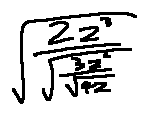Convert formula to latex. <formula><loc_0><loc_0><loc_500><loc_500>\sqrt { \frac { 2 z ^ { 3 } } { \sqrt { \frac { 3 z ^ { 2 } } { \sqrt { 4 z } } } } }</formula> 